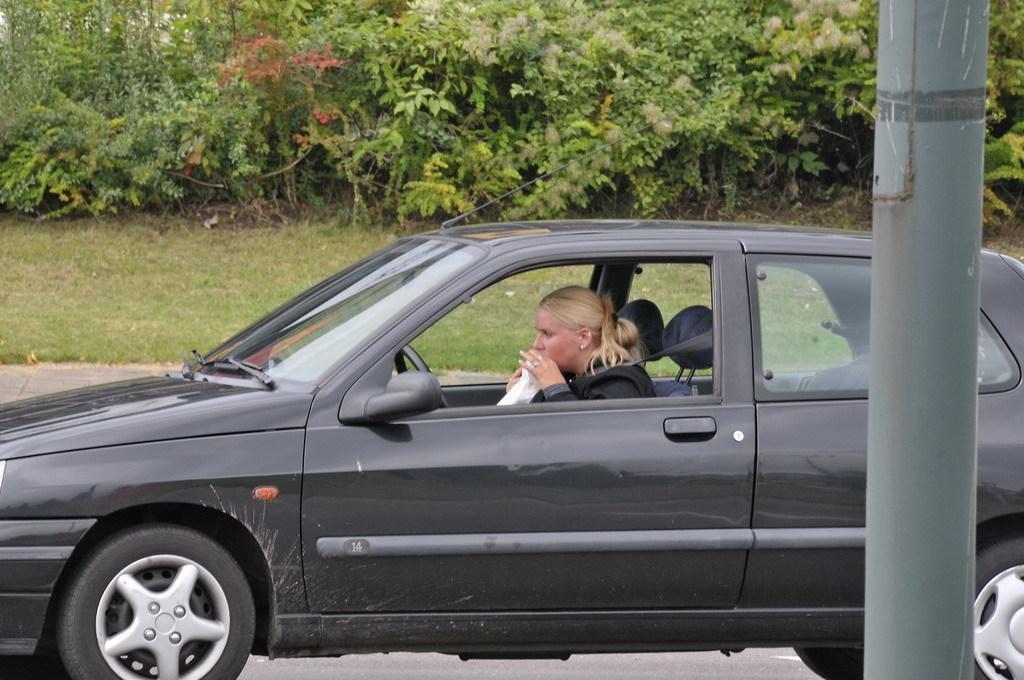Please provide a concise description of this image. in this image the woman is sitting in the car the other side the plant is there in the grassy land and she is holding some cloth and the background is very greenery. 